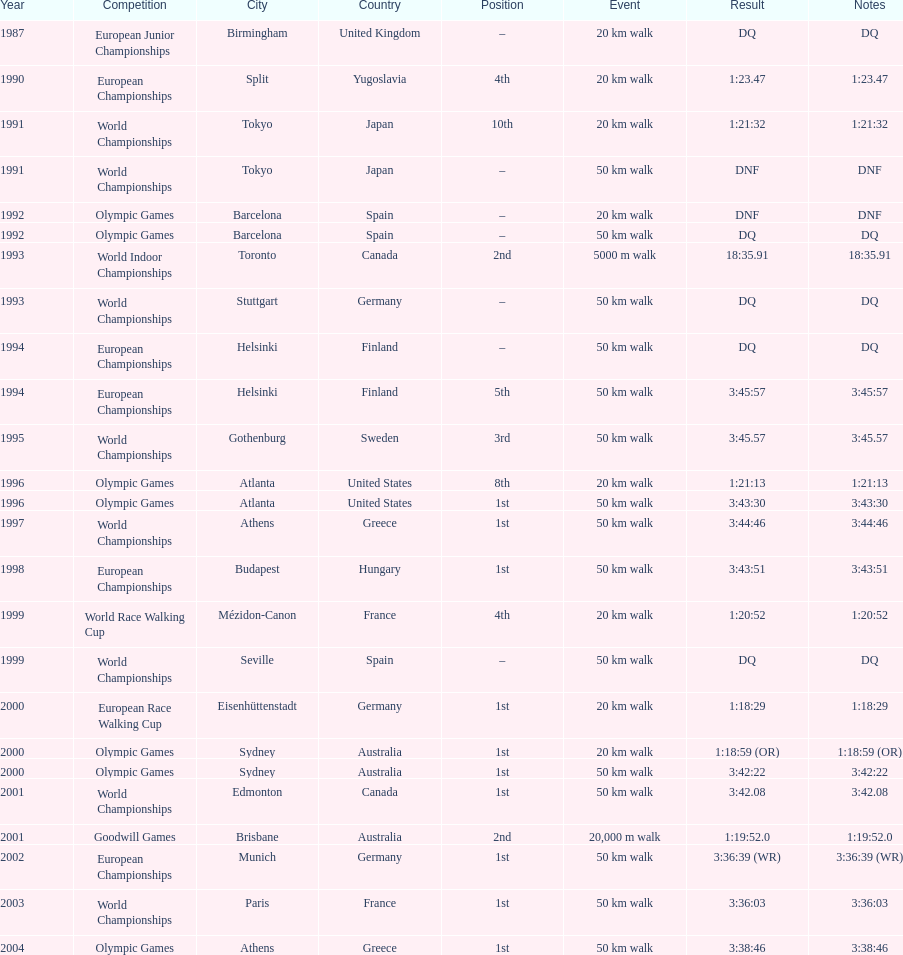I'm looking to parse the entire table for insights. Could you assist me with that? {'header': ['Year', 'Competition', 'City', 'Country', 'Position', 'Event', 'Result', 'Notes'], 'rows': [['1987', 'European Junior Championships', 'Birmingham', 'United Kingdom', '–', '20\xa0km walk', 'DQ', 'DQ'], ['1990', 'European Championships', 'Split', 'Yugoslavia', '4th', '20\xa0km walk', '1:23.47', '1:23.47'], ['1991', 'World Championships', 'Tokyo', 'Japan', '10th', '20\xa0km walk', '1:21:32', '1:21:32'], ['1991', 'World Championships', 'Tokyo', 'Japan', '–', '50\xa0km walk', 'DNF', 'DNF'], ['1992', 'Olympic Games', 'Barcelona', 'Spain', '–', '20\xa0km walk', 'DNF', 'DNF'], ['1992', 'Olympic Games', 'Barcelona', 'Spain', '–', '50\xa0km walk', 'DQ', 'DQ'], ['1993', 'World Indoor Championships', 'Toronto', 'Canada', '2nd', '5000 m walk', '18:35.91', '18:35.91'], ['1993', 'World Championships', 'Stuttgart', 'Germany', '–', '50\xa0km walk', 'DQ', 'DQ'], ['1994', 'European Championships', 'Helsinki', 'Finland', '–', '50\xa0km walk', 'DQ', 'DQ'], ['1994', 'European Championships', 'Helsinki', 'Finland', '5th', '50\xa0km walk', '3:45:57', '3:45:57'], ['1995', 'World Championships', 'Gothenburg', 'Sweden', '3rd', '50\xa0km walk', '3:45.57', '3:45.57'], ['1996', 'Olympic Games', 'Atlanta', 'United States', '8th', '20\xa0km walk', '1:21:13', '1:21:13'], ['1996', 'Olympic Games', 'Atlanta', 'United States', '1st', '50\xa0km walk', '3:43:30', '3:43:30'], ['1997', 'World Championships', 'Athens', 'Greece', '1st', '50\xa0km walk', '3:44:46', '3:44:46'], ['1998', 'European Championships', 'Budapest', 'Hungary', '1st', '50\xa0km walk', '3:43:51', '3:43:51'], ['1999', 'World Race Walking Cup', 'Mézidon-Canon', 'France', '4th', '20\xa0km walk', '1:20:52', '1:20:52'], ['1999', 'World Championships', 'Seville', 'Spain', '–', '50\xa0km walk', 'DQ', 'DQ'], ['2000', 'European Race Walking Cup', 'Eisenhüttenstadt', 'Germany', '1st', '20\xa0km walk', '1:18:29', '1:18:29'], ['2000', 'Olympic Games', 'Sydney', 'Australia', '1st', '20\xa0km walk', '1:18:59 (OR)', '1:18:59 (OR)'], ['2000', 'Olympic Games', 'Sydney', 'Australia', '1st', '50\xa0km walk', '3:42:22', '3:42:22'], ['2001', 'World Championships', 'Edmonton', 'Canada', '1st', '50\xa0km walk', '3:42.08', '3:42.08'], ['2001', 'Goodwill Games', 'Brisbane', 'Australia', '2nd', '20,000 m walk', '1:19:52.0', '1:19:52.0'], ['2002', 'European Championships', 'Munich', 'Germany', '1st', '50\xa0km walk', '3:36:39 (WR)', '3:36:39 (WR)'], ['2003', 'World Championships', 'Paris', 'France', '1st', '50\xa0km walk', '3:36:03', '3:36:03'], ['2004', 'Olympic Games', 'Athens', 'Greece', '1st', '50\xa0km walk', '3:38:46', '3:38:46']]} In what year was korzeniowski's last competition? 2004. 